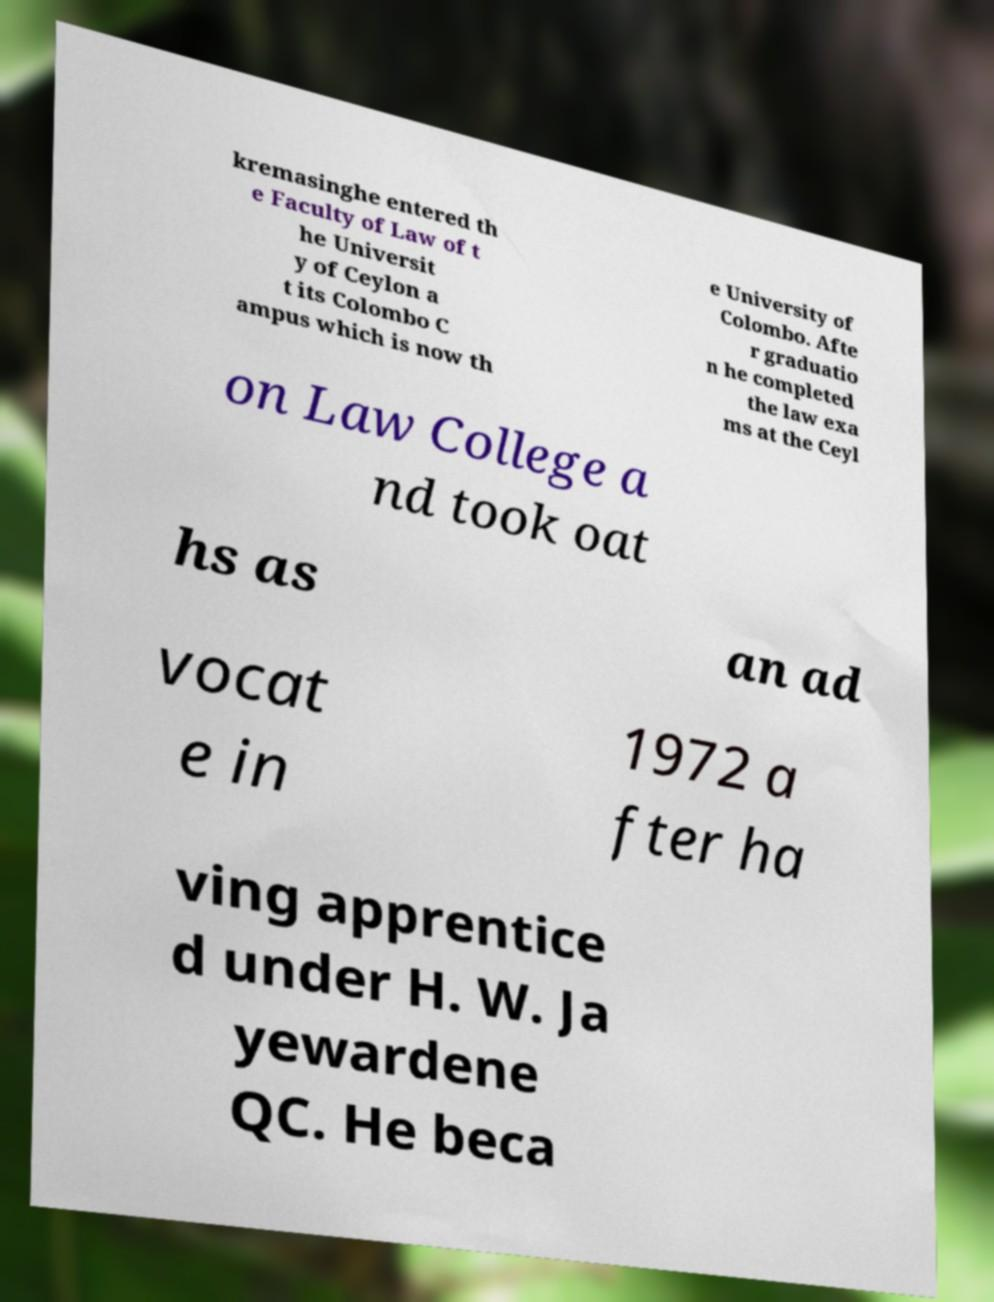There's text embedded in this image that I need extracted. Can you transcribe it verbatim? kremasinghe entered th e Faculty of Law of t he Universit y of Ceylon a t its Colombo C ampus which is now th e University of Colombo. Afte r graduatio n he completed the law exa ms at the Ceyl on Law College a nd took oat hs as an ad vocat e in 1972 a fter ha ving apprentice d under H. W. Ja yewardene QC. He beca 